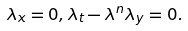<formula> <loc_0><loc_0><loc_500><loc_500>\lambda _ { x } = 0 , \lambda _ { t } - \lambda ^ { n } \lambda _ { y } = 0 .</formula> 